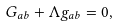<formula> <loc_0><loc_0><loc_500><loc_500>G _ { a b } + \Lambda g _ { a b } = 0 ,</formula> 